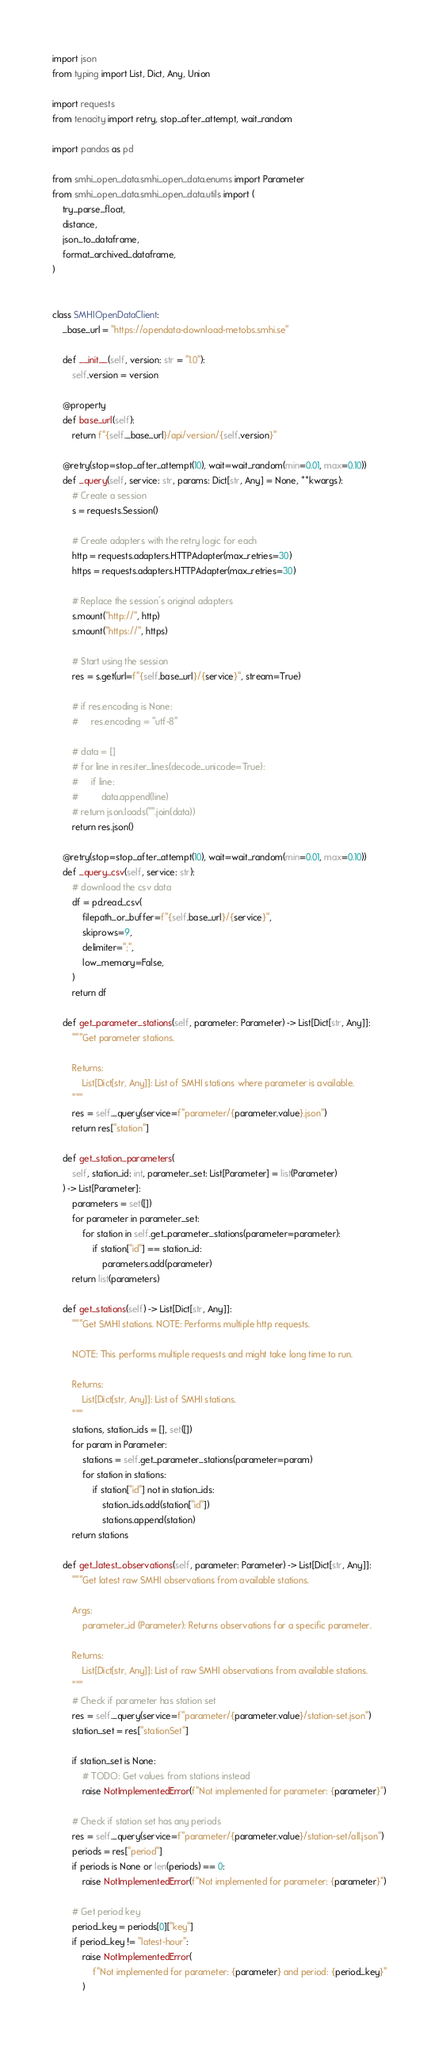<code> <loc_0><loc_0><loc_500><loc_500><_Python_>import json
from typing import List, Dict, Any, Union

import requests
from tenacity import retry, stop_after_attempt, wait_random

import pandas as pd

from smhi_open_data.smhi_open_data.enums import Parameter
from smhi_open_data.smhi_open_data.utils import (
    try_parse_float,
    distance,
    json_to_dataframe,
    format_archived_dataframe,
)


class SMHIOpenDataClient:
    _base_url = "https://opendata-download-metobs.smhi.se"

    def __init__(self, version: str = "1.0"):
        self.version = version

    @property
    def base_url(self):
        return f"{self._base_url}/api/version/{self.version}"

    @retry(stop=stop_after_attempt(10), wait=wait_random(min=0.01, max=0.10))
    def _query(self, service: str, params: Dict[str, Any] = None, **kwargs):
        # Create a session
        s = requests.Session()

        # Create adapters with the retry logic for each
        http = requests.adapters.HTTPAdapter(max_retries=30)
        https = requests.adapters.HTTPAdapter(max_retries=30)

        # Replace the session's original adapters
        s.mount("http://", http)
        s.mount("https://", https)

        # Start using the session
        res = s.get(url=f"{self.base_url}/{service}", stream=True)

        # if res.encoding is None:
        #     res.encoding = "utf-8"

        # data = []
        # for line in res.iter_lines(decode_unicode=True):
        #     if line:
        #         data.append(line)
        # return json.loads("".join(data))
        return res.json()

    @retry(stop=stop_after_attempt(10), wait=wait_random(min=0.01, max=0.10))
    def _query_csv(self, service: str):
        # download the csv data
        df = pd.read_csv(
            filepath_or_buffer=f"{self.base_url}/{service}",
            skiprows=9,
            delimiter=";",
            low_memory=False,
        )
        return df

    def get_parameter_stations(self, parameter: Parameter) -> List[Dict[str, Any]]:
        """Get parameter stations.

        Returns:
            List[Dict[str, Any]]: List of SMHI stations where parameter is available.
        """
        res = self._query(service=f"parameter/{parameter.value}.json")
        return res["station"]

    def get_station_parameters(
        self, station_id: int, parameter_set: List[Parameter] = list(Parameter)
    ) -> List[Parameter]:
        parameters = set([])
        for parameter in parameter_set:
            for station in self.get_parameter_stations(parameter=parameter):
                if station["id"] == station_id:
                    parameters.add(parameter)
        return list(parameters)

    def get_stations(self) -> List[Dict[str, Any]]:
        """Get SMHI stations. NOTE: Performs multiple http requests.

        NOTE: This performs multiple requests and might take long time to run.

        Returns:
            List[Dict[str, Any]]: List of SMHI stations.
        """
        stations, station_ids = [], set([])
        for param in Parameter:
            stations = self.get_parameter_stations(parameter=param)
            for station in stations:
                if station["id"] not in station_ids:
                    station_ids.add(station["id"])
                    stations.append(station)
        return stations

    def get_latest_observations(self, parameter: Parameter) -> List[Dict[str, Any]]:
        """Get latest raw SMHI observations from available stations.

        Args:
            parameter_id (Parameter): Returns observations for a specific parameter.

        Returns:
            List[Dict[str, Any]]: List of raw SMHI observations from available stations.
        """
        # Check if parameter has station set
        res = self._query(service=f"parameter/{parameter.value}/station-set.json")
        station_set = res["stationSet"]

        if station_set is None:
            # TODO: Get values from stations instead
            raise NotImplementedError(f"Not implemented for parameter: {parameter}")

        # Check if station set has any periods
        res = self._query(service=f"parameter/{parameter.value}/station-set/all.json")
        periods = res["period"]
        if periods is None or len(periods) == 0:
            raise NotImplementedError(f"Not implemented for parameter: {parameter}")

        # Get period key
        period_key = periods[0]["key"]
        if period_key != "latest-hour":
            raise NotImplementedError(
                f"Not implemented for parameter: {parameter} and period: {period_key}"
            )
</code> 